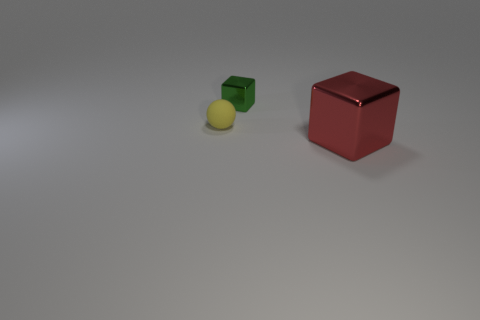Is there any pattern or alignment to how the objects are placed? The objects are arranged with no apparent pattern or alignment; they are placed randomly across a flat surface. Could you infer anything about the lighting in the scene? The lighting in the scene appears to be uniform and diffused, with soft shadows cast by the objects, suggesting an overhead source that is not overly harsh or direct. 